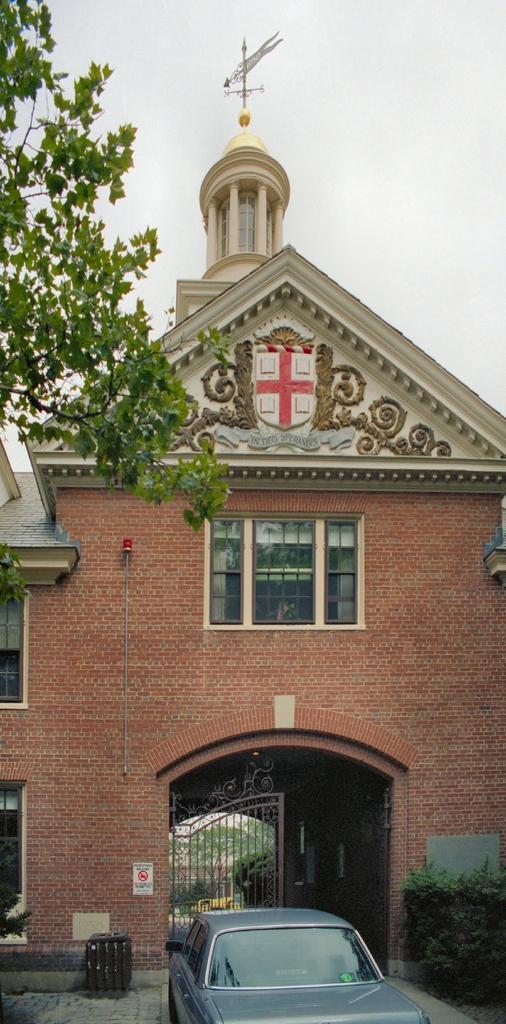Could you give a brief overview of what you see in this image? In this picture we can see a car on the road, gates, plants, trees, signboard, building with windows and some objects and in the background we can see the sky. 